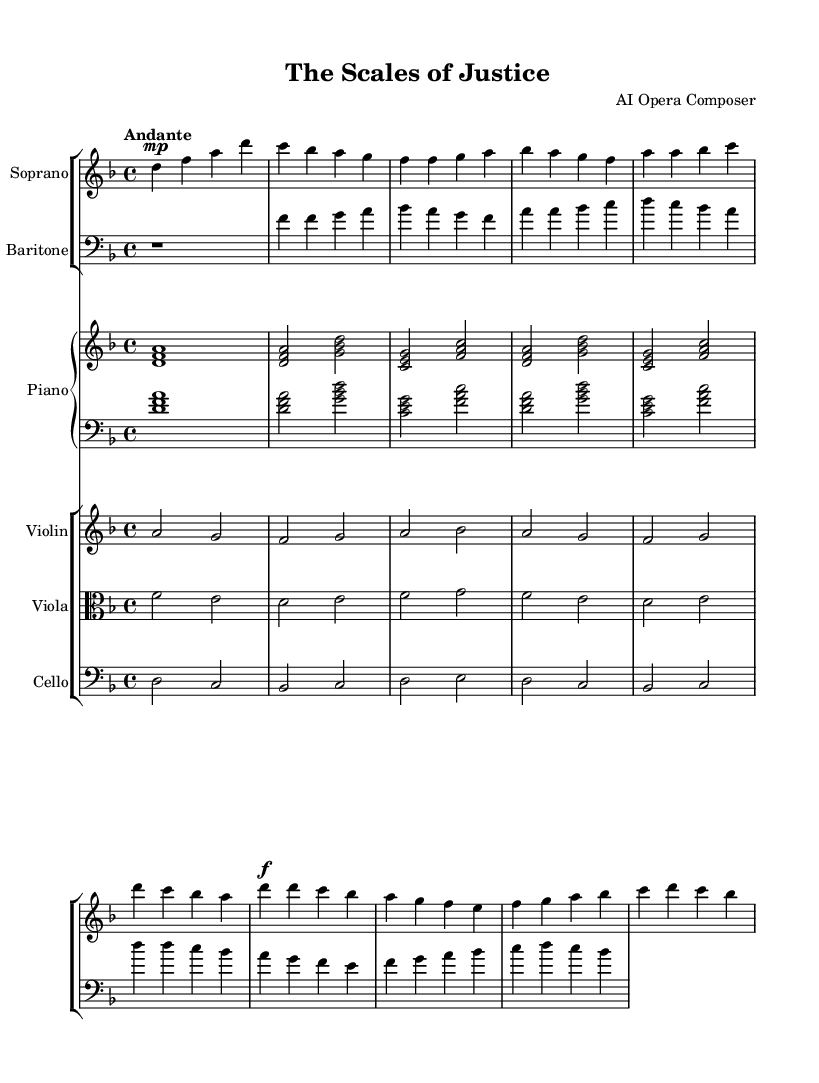What is the key signature of this music? The key signature is indicated at the beginning of the score, showing two flats, which signifies the key of D minor.
Answer: D minor What is the time signature of this piece? The time signature is found at the beginning of the score next to the key signature; it is displayed as 4/4, meaning there are four beats per measure.
Answer: 4/4 What is the tempo marking for this music? The tempo marking is also present at the beginning of the score and indicates the speed of the piece; it reads "Andante," which suggests a moderate pace.
Answer: Andante How many bars are in the introduction section? Looking at the music, the introduction for both the soprano and the piano consists of one bar each, totaling two bars in the introduction section.
Answer: 2 bars Which instruments are included in this score? By observing the score layout, the instruments listed are soprano, baritone, piano, violin, viola, and cello, each displayed in separate staff groups.
Answer: Soprano, Baritone, Piano, Violin, Viola, Cello What theme does the chorus's lyrics convey? The lyrics of the chorus express a notion of integrity and guidance, highlighted by phrases like "In -- te -- gri -- ty, our com -- pass true and bright," indicating themes of moral direction in legal practice.
Answer: Integrity and guidance How is the dynamic indicated for the soprano part in the chorus? In the chorus section, the dynamic marking is shown as "f," which stands for forte, implying that this part should be played loudly.
Answer: Forte 